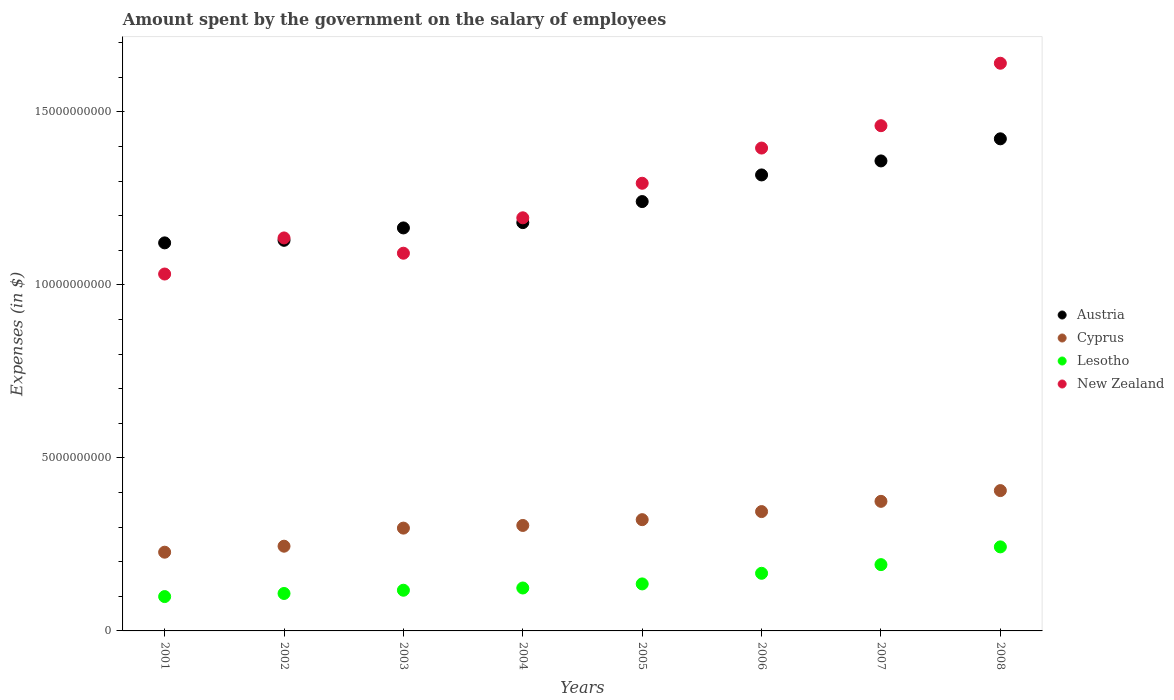How many different coloured dotlines are there?
Provide a short and direct response. 4. What is the amount spent on the salary of employees by the government in Lesotho in 2003?
Ensure brevity in your answer.  1.18e+09. Across all years, what is the maximum amount spent on the salary of employees by the government in Cyprus?
Offer a terse response. 4.06e+09. Across all years, what is the minimum amount spent on the salary of employees by the government in New Zealand?
Offer a terse response. 1.03e+1. In which year was the amount spent on the salary of employees by the government in Lesotho maximum?
Keep it short and to the point. 2008. In which year was the amount spent on the salary of employees by the government in Cyprus minimum?
Ensure brevity in your answer.  2001. What is the total amount spent on the salary of employees by the government in Lesotho in the graph?
Keep it short and to the point. 1.19e+1. What is the difference between the amount spent on the salary of employees by the government in New Zealand in 2002 and that in 2008?
Ensure brevity in your answer.  -5.05e+09. What is the difference between the amount spent on the salary of employees by the government in Lesotho in 2001 and the amount spent on the salary of employees by the government in New Zealand in 2005?
Your answer should be compact. -1.19e+1. What is the average amount spent on the salary of employees by the government in Austria per year?
Provide a short and direct response. 1.24e+1. In the year 2006, what is the difference between the amount spent on the salary of employees by the government in New Zealand and amount spent on the salary of employees by the government in Cyprus?
Your response must be concise. 1.05e+1. In how many years, is the amount spent on the salary of employees by the government in New Zealand greater than 12000000000 $?
Your answer should be very brief. 4. What is the ratio of the amount spent on the salary of employees by the government in Cyprus in 2003 to that in 2007?
Give a very brief answer. 0.79. Is the amount spent on the salary of employees by the government in Cyprus in 2002 less than that in 2003?
Keep it short and to the point. Yes. Is the difference between the amount spent on the salary of employees by the government in New Zealand in 2005 and 2008 greater than the difference between the amount spent on the salary of employees by the government in Cyprus in 2005 and 2008?
Your answer should be compact. No. What is the difference between the highest and the second highest amount spent on the salary of employees by the government in Austria?
Offer a very short reply. 6.39e+08. What is the difference between the highest and the lowest amount spent on the salary of employees by the government in Austria?
Ensure brevity in your answer.  3.01e+09. Is the sum of the amount spent on the salary of employees by the government in Lesotho in 2002 and 2005 greater than the maximum amount spent on the salary of employees by the government in Austria across all years?
Make the answer very short. No. Is the amount spent on the salary of employees by the government in Cyprus strictly less than the amount spent on the salary of employees by the government in Austria over the years?
Your response must be concise. Yes. How many dotlines are there?
Provide a short and direct response. 4. How many years are there in the graph?
Ensure brevity in your answer.  8. Are the values on the major ticks of Y-axis written in scientific E-notation?
Your answer should be compact. No. Does the graph contain grids?
Offer a very short reply. No. How many legend labels are there?
Your response must be concise. 4. What is the title of the graph?
Give a very brief answer. Amount spent by the government on the salary of employees. Does "St. Vincent and the Grenadines" appear as one of the legend labels in the graph?
Your answer should be very brief. No. What is the label or title of the Y-axis?
Provide a succinct answer. Expenses (in $). What is the Expenses (in $) of Austria in 2001?
Give a very brief answer. 1.12e+1. What is the Expenses (in $) in Cyprus in 2001?
Give a very brief answer. 2.28e+09. What is the Expenses (in $) of Lesotho in 2001?
Offer a terse response. 9.92e+08. What is the Expenses (in $) in New Zealand in 2001?
Give a very brief answer. 1.03e+1. What is the Expenses (in $) of Austria in 2002?
Your answer should be compact. 1.13e+1. What is the Expenses (in $) in Cyprus in 2002?
Your answer should be compact. 2.45e+09. What is the Expenses (in $) in Lesotho in 2002?
Your response must be concise. 1.08e+09. What is the Expenses (in $) in New Zealand in 2002?
Offer a very short reply. 1.14e+1. What is the Expenses (in $) in Austria in 2003?
Your answer should be very brief. 1.16e+1. What is the Expenses (in $) of Cyprus in 2003?
Provide a short and direct response. 2.97e+09. What is the Expenses (in $) in Lesotho in 2003?
Give a very brief answer. 1.18e+09. What is the Expenses (in $) of New Zealand in 2003?
Ensure brevity in your answer.  1.09e+1. What is the Expenses (in $) of Austria in 2004?
Your answer should be very brief. 1.18e+1. What is the Expenses (in $) in Cyprus in 2004?
Provide a short and direct response. 3.05e+09. What is the Expenses (in $) in Lesotho in 2004?
Your answer should be very brief. 1.24e+09. What is the Expenses (in $) of New Zealand in 2004?
Keep it short and to the point. 1.19e+1. What is the Expenses (in $) of Austria in 2005?
Keep it short and to the point. 1.24e+1. What is the Expenses (in $) of Cyprus in 2005?
Offer a very short reply. 3.22e+09. What is the Expenses (in $) in Lesotho in 2005?
Give a very brief answer. 1.36e+09. What is the Expenses (in $) of New Zealand in 2005?
Offer a very short reply. 1.29e+1. What is the Expenses (in $) in Austria in 2006?
Provide a short and direct response. 1.32e+1. What is the Expenses (in $) of Cyprus in 2006?
Keep it short and to the point. 3.45e+09. What is the Expenses (in $) in Lesotho in 2006?
Your answer should be compact. 1.67e+09. What is the Expenses (in $) in New Zealand in 2006?
Your response must be concise. 1.40e+1. What is the Expenses (in $) of Austria in 2007?
Give a very brief answer. 1.36e+1. What is the Expenses (in $) in Cyprus in 2007?
Keep it short and to the point. 3.74e+09. What is the Expenses (in $) of Lesotho in 2007?
Keep it short and to the point. 1.92e+09. What is the Expenses (in $) of New Zealand in 2007?
Your response must be concise. 1.46e+1. What is the Expenses (in $) in Austria in 2008?
Your answer should be very brief. 1.42e+1. What is the Expenses (in $) of Cyprus in 2008?
Offer a terse response. 4.06e+09. What is the Expenses (in $) in Lesotho in 2008?
Provide a short and direct response. 2.43e+09. What is the Expenses (in $) of New Zealand in 2008?
Ensure brevity in your answer.  1.64e+1. Across all years, what is the maximum Expenses (in $) in Austria?
Offer a very short reply. 1.42e+1. Across all years, what is the maximum Expenses (in $) in Cyprus?
Make the answer very short. 4.06e+09. Across all years, what is the maximum Expenses (in $) in Lesotho?
Your answer should be very brief. 2.43e+09. Across all years, what is the maximum Expenses (in $) of New Zealand?
Keep it short and to the point. 1.64e+1. Across all years, what is the minimum Expenses (in $) in Austria?
Ensure brevity in your answer.  1.12e+1. Across all years, what is the minimum Expenses (in $) in Cyprus?
Give a very brief answer. 2.28e+09. Across all years, what is the minimum Expenses (in $) in Lesotho?
Make the answer very short. 9.92e+08. Across all years, what is the minimum Expenses (in $) of New Zealand?
Give a very brief answer. 1.03e+1. What is the total Expenses (in $) of Austria in the graph?
Give a very brief answer. 9.93e+1. What is the total Expenses (in $) of Cyprus in the graph?
Keep it short and to the point. 2.52e+1. What is the total Expenses (in $) of Lesotho in the graph?
Offer a terse response. 1.19e+1. What is the total Expenses (in $) in New Zealand in the graph?
Ensure brevity in your answer.  1.02e+11. What is the difference between the Expenses (in $) in Austria in 2001 and that in 2002?
Ensure brevity in your answer.  -7.44e+07. What is the difference between the Expenses (in $) in Cyprus in 2001 and that in 2002?
Your answer should be very brief. -1.73e+08. What is the difference between the Expenses (in $) in Lesotho in 2001 and that in 2002?
Provide a succinct answer. -8.97e+07. What is the difference between the Expenses (in $) in New Zealand in 2001 and that in 2002?
Ensure brevity in your answer.  -1.04e+09. What is the difference between the Expenses (in $) in Austria in 2001 and that in 2003?
Your response must be concise. -4.32e+08. What is the difference between the Expenses (in $) of Cyprus in 2001 and that in 2003?
Make the answer very short. -6.96e+08. What is the difference between the Expenses (in $) in Lesotho in 2001 and that in 2003?
Make the answer very short. -1.83e+08. What is the difference between the Expenses (in $) of New Zealand in 2001 and that in 2003?
Provide a short and direct response. -6.01e+08. What is the difference between the Expenses (in $) of Austria in 2001 and that in 2004?
Provide a succinct answer. -5.86e+08. What is the difference between the Expenses (in $) in Cyprus in 2001 and that in 2004?
Your response must be concise. -7.73e+08. What is the difference between the Expenses (in $) of Lesotho in 2001 and that in 2004?
Your answer should be compact. -2.48e+08. What is the difference between the Expenses (in $) in New Zealand in 2001 and that in 2004?
Provide a short and direct response. -1.62e+09. What is the difference between the Expenses (in $) of Austria in 2001 and that in 2005?
Keep it short and to the point. -1.19e+09. What is the difference between the Expenses (in $) in Cyprus in 2001 and that in 2005?
Ensure brevity in your answer.  -9.40e+08. What is the difference between the Expenses (in $) of Lesotho in 2001 and that in 2005?
Offer a terse response. -3.66e+08. What is the difference between the Expenses (in $) in New Zealand in 2001 and that in 2005?
Offer a terse response. -2.62e+09. What is the difference between the Expenses (in $) of Austria in 2001 and that in 2006?
Your response must be concise. -1.96e+09. What is the difference between the Expenses (in $) of Cyprus in 2001 and that in 2006?
Provide a short and direct response. -1.17e+09. What is the difference between the Expenses (in $) of Lesotho in 2001 and that in 2006?
Your response must be concise. -6.73e+08. What is the difference between the Expenses (in $) of New Zealand in 2001 and that in 2006?
Your answer should be very brief. -3.64e+09. What is the difference between the Expenses (in $) of Austria in 2001 and that in 2007?
Provide a succinct answer. -2.37e+09. What is the difference between the Expenses (in $) in Cyprus in 2001 and that in 2007?
Make the answer very short. -1.47e+09. What is the difference between the Expenses (in $) of Lesotho in 2001 and that in 2007?
Provide a short and direct response. -9.23e+08. What is the difference between the Expenses (in $) of New Zealand in 2001 and that in 2007?
Your answer should be compact. -4.29e+09. What is the difference between the Expenses (in $) in Austria in 2001 and that in 2008?
Keep it short and to the point. -3.01e+09. What is the difference between the Expenses (in $) of Cyprus in 2001 and that in 2008?
Your response must be concise. -1.78e+09. What is the difference between the Expenses (in $) in Lesotho in 2001 and that in 2008?
Provide a short and direct response. -1.44e+09. What is the difference between the Expenses (in $) in New Zealand in 2001 and that in 2008?
Offer a very short reply. -6.09e+09. What is the difference between the Expenses (in $) of Austria in 2002 and that in 2003?
Ensure brevity in your answer.  -3.58e+08. What is the difference between the Expenses (in $) in Cyprus in 2002 and that in 2003?
Give a very brief answer. -5.22e+08. What is the difference between the Expenses (in $) of Lesotho in 2002 and that in 2003?
Provide a succinct answer. -9.38e+07. What is the difference between the Expenses (in $) of New Zealand in 2002 and that in 2003?
Your answer should be very brief. 4.41e+08. What is the difference between the Expenses (in $) of Austria in 2002 and that in 2004?
Ensure brevity in your answer.  -5.11e+08. What is the difference between the Expenses (in $) in Cyprus in 2002 and that in 2004?
Your answer should be compact. -5.99e+08. What is the difference between the Expenses (in $) of Lesotho in 2002 and that in 2004?
Provide a succinct answer. -1.58e+08. What is the difference between the Expenses (in $) of New Zealand in 2002 and that in 2004?
Provide a short and direct response. -5.82e+08. What is the difference between the Expenses (in $) of Austria in 2002 and that in 2005?
Offer a terse response. -1.12e+09. What is the difference between the Expenses (in $) in Cyprus in 2002 and that in 2005?
Your response must be concise. -7.67e+08. What is the difference between the Expenses (in $) of Lesotho in 2002 and that in 2005?
Your answer should be very brief. -2.76e+08. What is the difference between the Expenses (in $) of New Zealand in 2002 and that in 2005?
Your answer should be compact. -1.58e+09. What is the difference between the Expenses (in $) in Austria in 2002 and that in 2006?
Your answer should be very brief. -1.89e+09. What is the difference between the Expenses (in $) of Cyprus in 2002 and that in 2006?
Your answer should be very brief. -1.00e+09. What is the difference between the Expenses (in $) of Lesotho in 2002 and that in 2006?
Make the answer very short. -5.83e+08. What is the difference between the Expenses (in $) in New Zealand in 2002 and that in 2006?
Your response must be concise. -2.60e+09. What is the difference between the Expenses (in $) in Austria in 2002 and that in 2007?
Give a very brief answer. -2.29e+09. What is the difference between the Expenses (in $) in Cyprus in 2002 and that in 2007?
Keep it short and to the point. -1.30e+09. What is the difference between the Expenses (in $) of Lesotho in 2002 and that in 2007?
Ensure brevity in your answer.  -8.34e+08. What is the difference between the Expenses (in $) in New Zealand in 2002 and that in 2007?
Ensure brevity in your answer.  -3.24e+09. What is the difference between the Expenses (in $) of Austria in 2002 and that in 2008?
Your answer should be very brief. -2.93e+09. What is the difference between the Expenses (in $) in Cyprus in 2002 and that in 2008?
Ensure brevity in your answer.  -1.61e+09. What is the difference between the Expenses (in $) in Lesotho in 2002 and that in 2008?
Your answer should be very brief. -1.35e+09. What is the difference between the Expenses (in $) in New Zealand in 2002 and that in 2008?
Offer a very short reply. -5.05e+09. What is the difference between the Expenses (in $) of Austria in 2003 and that in 2004?
Your answer should be very brief. -1.53e+08. What is the difference between the Expenses (in $) of Cyprus in 2003 and that in 2004?
Give a very brief answer. -7.69e+07. What is the difference between the Expenses (in $) of Lesotho in 2003 and that in 2004?
Provide a short and direct response. -6.46e+07. What is the difference between the Expenses (in $) in New Zealand in 2003 and that in 2004?
Give a very brief answer. -1.02e+09. What is the difference between the Expenses (in $) of Austria in 2003 and that in 2005?
Make the answer very short. -7.62e+08. What is the difference between the Expenses (in $) of Cyprus in 2003 and that in 2005?
Keep it short and to the point. -2.44e+08. What is the difference between the Expenses (in $) of Lesotho in 2003 and that in 2005?
Your response must be concise. -1.82e+08. What is the difference between the Expenses (in $) in New Zealand in 2003 and that in 2005?
Provide a succinct answer. -2.02e+09. What is the difference between the Expenses (in $) in Austria in 2003 and that in 2006?
Your answer should be compact. -1.53e+09. What is the difference between the Expenses (in $) in Cyprus in 2003 and that in 2006?
Offer a very short reply. -4.78e+08. What is the difference between the Expenses (in $) of Lesotho in 2003 and that in 2006?
Your answer should be compact. -4.90e+08. What is the difference between the Expenses (in $) in New Zealand in 2003 and that in 2006?
Your response must be concise. -3.04e+09. What is the difference between the Expenses (in $) of Austria in 2003 and that in 2007?
Ensure brevity in your answer.  -1.94e+09. What is the difference between the Expenses (in $) in Cyprus in 2003 and that in 2007?
Make the answer very short. -7.74e+08. What is the difference between the Expenses (in $) in Lesotho in 2003 and that in 2007?
Your answer should be compact. -7.40e+08. What is the difference between the Expenses (in $) in New Zealand in 2003 and that in 2007?
Your answer should be compact. -3.68e+09. What is the difference between the Expenses (in $) of Austria in 2003 and that in 2008?
Offer a terse response. -2.57e+09. What is the difference between the Expenses (in $) of Cyprus in 2003 and that in 2008?
Offer a terse response. -1.08e+09. What is the difference between the Expenses (in $) in Lesotho in 2003 and that in 2008?
Keep it short and to the point. -1.25e+09. What is the difference between the Expenses (in $) in New Zealand in 2003 and that in 2008?
Keep it short and to the point. -5.49e+09. What is the difference between the Expenses (in $) of Austria in 2004 and that in 2005?
Your answer should be very brief. -6.08e+08. What is the difference between the Expenses (in $) in Cyprus in 2004 and that in 2005?
Give a very brief answer. -1.67e+08. What is the difference between the Expenses (in $) in Lesotho in 2004 and that in 2005?
Provide a succinct answer. -1.18e+08. What is the difference between the Expenses (in $) in New Zealand in 2004 and that in 2005?
Ensure brevity in your answer.  -9.98e+08. What is the difference between the Expenses (in $) in Austria in 2004 and that in 2006?
Provide a short and direct response. -1.38e+09. What is the difference between the Expenses (in $) in Cyprus in 2004 and that in 2006?
Give a very brief answer. -4.01e+08. What is the difference between the Expenses (in $) in Lesotho in 2004 and that in 2006?
Offer a terse response. -4.25e+08. What is the difference between the Expenses (in $) of New Zealand in 2004 and that in 2006?
Offer a very short reply. -2.02e+09. What is the difference between the Expenses (in $) of Austria in 2004 and that in 2007?
Provide a succinct answer. -1.78e+09. What is the difference between the Expenses (in $) in Cyprus in 2004 and that in 2007?
Provide a short and direct response. -6.97e+08. What is the difference between the Expenses (in $) in Lesotho in 2004 and that in 2007?
Keep it short and to the point. -6.75e+08. What is the difference between the Expenses (in $) of New Zealand in 2004 and that in 2007?
Provide a short and direct response. -2.66e+09. What is the difference between the Expenses (in $) of Austria in 2004 and that in 2008?
Offer a very short reply. -2.42e+09. What is the difference between the Expenses (in $) in Cyprus in 2004 and that in 2008?
Provide a short and direct response. -1.01e+09. What is the difference between the Expenses (in $) of Lesotho in 2004 and that in 2008?
Your answer should be compact. -1.19e+09. What is the difference between the Expenses (in $) in New Zealand in 2004 and that in 2008?
Make the answer very short. -4.47e+09. What is the difference between the Expenses (in $) in Austria in 2005 and that in 2006?
Ensure brevity in your answer.  -7.70e+08. What is the difference between the Expenses (in $) in Cyprus in 2005 and that in 2006?
Offer a terse response. -2.33e+08. What is the difference between the Expenses (in $) of Lesotho in 2005 and that in 2006?
Provide a short and direct response. -3.07e+08. What is the difference between the Expenses (in $) in New Zealand in 2005 and that in 2006?
Provide a succinct answer. -1.02e+09. What is the difference between the Expenses (in $) of Austria in 2005 and that in 2007?
Your answer should be compact. -1.17e+09. What is the difference between the Expenses (in $) in Cyprus in 2005 and that in 2007?
Provide a short and direct response. -5.29e+08. What is the difference between the Expenses (in $) of Lesotho in 2005 and that in 2007?
Make the answer very short. -5.57e+08. What is the difference between the Expenses (in $) in New Zealand in 2005 and that in 2007?
Your answer should be compact. -1.66e+09. What is the difference between the Expenses (in $) of Austria in 2005 and that in 2008?
Your answer should be compact. -1.81e+09. What is the difference between the Expenses (in $) in Cyprus in 2005 and that in 2008?
Make the answer very short. -8.40e+08. What is the difference between the Expenses (in $) of Lesotho in 2005 and that in 2008?
Offer a terse response. -1.07e+09. What is the difference between the Expenses (in $) in New Zealand in 2005 and that in 2008?
Your answer should be very brief. -3.47e+09. What is the difference between the Expenses (in $) of Austria in 2006 and that in 2007?
Make the answer very short. -4.05e+08. What is the difference between the Expenses (in $) of Cyprus in 2006 and that in 2007?
Give a very brief answer. -2.96e+08. What is the difference between the Expenses (in $) in Lesotho in 2006 and that in 2007?
Offer a terse response. -2.50e+08. What is the difference between the Expenses (in $) of New Zealand in 2006 and that in 2007?
Keep it short and to the point. -6.46e+08. What is the difference between the Expenses (in $) in Austria in 2006 and that in 2008?
Your answer should be compact. -1.04e+09. What is the difference between the Expenses (in $) of Cyprus in 2006 and that in 2008?
Offer a terse response. -6.06e+08. What is the difference between the Expenses (in $) of Lesotho in 2006 and that in 2008?
Ensure brevity in your answer.  -7.63e+08. What is the difference between the Expenses (in $) of New Zealand in 2006 and that in 2008?
Keep it short and to the point. -2.45e+09. What is the difference between the Expenses (in $) of Austria in 2007 and that in 2008?
Your answer should be very brief. -6.39e+08. What is the difference between the Expenses (in $) in Cyprus in 2007 and that in 2008?
Provide a succinct answer. -3.10e+08. What is the difference between the Expenses (in $) in Lesotho in 2007 and that in 2008?
Provide a succinct answer. -5.13e+08. What is the difference between the Expenses (in $) of New Zealand in 2007 and that in 2008?
Provide a short and direct response. -1.80e+09. What is the difference between the Expenses (in $) in Austria in 2001 and the Expenses (in $) in Cyprus in 2002?
Your response must be concise. 8.77e+09. What is the difference between the Expenses (in $) in Austria in 2001 and the Expenses (in $) in Lesotho in 2002?
Make the answer very short. 1.01e+1. What is the difference between the Expenses (in $) of Austria in 2001 and the Expenses (in $) of New Zealand in 2002?
Your answer should be very brief. -1.42e+08. What is the difference between the Expenses (in $) in Cyprus in 2001 and the Expenses (in $) in Lesotho in 2002?
Make the answer very short. 1.19e+09. What is the difference between the Expenses (in $) in Cyprus in 2001 and the Expenses (in $) in New Zealand in 2002?
Your response must be concise. -9.08e+09. What is the difference between the Expenses (in $) of Lesotho in 2001 and the Expenses (in $) of New Zealand in 2002?
Offer a very short reply. -1.04e+1. What is the difference between the Expenses (in $) of Austria in 2001 and the Expenses (in $) of Cyprus in 2003?
Make the answer very short. 8.24e+09. What is the difference between the Expenses (in $) in Austria in 2001 and the Expenses (in $) in Lesotho in 2003?
Make the answer very short. 1.00e+1. What is the difference between the Expenses (in $) of Austria in 2001 and the Expenses (in $) of New Zealand in 2003?
Your answer should be very brief. 2.99e+08. What is the difference between the Expenses (in $) of Cyprus in 2001 and the Expenses (in $) of Lesotho in 2003?
Your response must be concise. 1.10e+09. What is the difference between the Expenses (in $) in Cyprus in 2001 and the Expenses (in $) in New Zealand in 2003?
Offer a very short reply. -8.64e+09. What is the difference between the Expenses (in $) of Lesotho in 2001 and the Expenses (in $) of New Zealand in 2003?
Your answer should be very brief. -9.92e+09. What is the difference between the Expenses (in $) in Austria in 2001 and the Expenses (in $) in Cyprus in 2004?
Provide a succinct answer. 8.17e+09. What is the difference between the Expenses (in $) of Austria in 2001 and the Expenses (in $) of Lesotho in 2004?
Keep it short and to the point. 9.97e+09. What is the difference between the Expenses (in $) of Austria in 2001 and the Expenses (in $) of New Zealand in 2004?
Your response must be concise. -7.25e+08. What is the difference between the Expenses (in $) of Cyprus in 2001 and the Expenses (in $) of Lesotho in 2004?
Your response must be concise. 1.03e+09. What is the difference between the Expenses (in $) of Cyprus in 2001 and the Expenses (in $) of New Zealand in 2004?
Offer a terse response. -9.66e+09. What is the difference between the Expenses (in $) in Lesotho in 2001 and the Expenses (in $) in New Zealand in 2004?
Make the answer very short. -1.09e+1. What is the difference between the Expenses (in $) of Austria in 2001 and the Expenses (in $) of Cyprus in 2005?
Provide a short and direct response. 8.00e+09. What is the difference between the Expenses (in $) in Austria in 2001 and the Expenses (in $) in Lesotho in 2005?
Your response must be concise. 9.86e+09. What is the difference between the Expenses (in $) in Austria in 2001 and the Expenses (in $) in New Zealand in 2005?
Offer a very short reply. -1.72e+09. What is the difference between the Expenses (in $) in Cyprus in 2001 and the Expenses (in $) in Lesotho in 2005?
Give a very brief answer. 9.17e+08. What is the difference between the Expenses (in $) in Cyprus in 2001 and the Expenses (in $) in New Zealand in 2005?
Give a very brief answer. -1.07e+1. What is the difference between the Expenses (in $) of Lesotho in 2001 and the Expenses (in $) of New Zealand in 2005?
Make the answer very short. -1.19e+1. What is the difference between the Expenses (in $) of Austria in 2001 and the Expenses (in $) of Cyprus in 2006?
Ensure brevity in your answer.  7.77e+09. What is the difference between the Expenses (in $) in Austria in 2001 and the Expenses (in $) in Lesotho in 2006?
Offer a very short reply. 9.55e+09. What is the difference between the Expenses (in $) in Austria in 2001 and the Expenses (in $) in New Zealand in 2006?
Provide a short and direct response. -2.74e+09. What is the difference between the Expenses (in $) of Cyprus in 2001 and the Expenses (in $) of Lesotho in 2006?
Your response must be concise. 6.10e+08. What is the difference between the Expenses (in $) in Cyprus in 2001 and the Expenses (in $) in New Zealand in 2006?
Make the answer very short. -1.17e+1. What is the difference between the Expenses (in $) of Lesotho in 2001 and the Expenses (in $) of New Zealand in 2006?
Your response must be concise. -1.30e+1. What is the difference between the Expenses (in $) of Austria in 2001 and the Expenses (in $) of Cyprus in 2007?
Your response must be concise. 7.47e+09. What is the difference between the Expenses (in $) of Austria in 2001 and the Expenses (in $) of Lesotho in 2007?
Ensure brevity in your answer.  9.30e+09. What is the difference between the Expenses (in $) of Austria in 2001 and the Expenses (in $) of New Zealand in 2007?
Provide a short and direct response. -3.39e+09. What is the difference between the Expenses (in $) of Cyprus in 2001 and the Expenses (in $) of Lesotho in 2007?
Your response must be concise. 3.60e+08. What is the difference between the Expenses (in $) in Cyprus in 2001 and the Expenses (in $) in New Zealand in 2007?
Provide a short and direct response. -1.23e+1. What is the difference between the Expenses (in $) of Lesotho in 2001 and the Expenses (in $) of New Zealand in 2007?
Ensure brevity in your answer.  -1.36e+1. What is the difference between the Expenses (in $) in Austria in 2001 and the Expenses (in $) in Cyprus in 2008?
Your response must be concise. 7.16e+09. What is the difference between the Expenses (in $) in Austria in 2001 and the Expenses (in $) in Lesotho in 2008?
Offer a very short reply. 8.79e+09. What is the difference between the Expenses (in $) of Austria in 2001 and the Expenses (in $) of New Zealand in 2008?
Provide a short and direct response. -5.19e+09. What is the difference between the Expenses (in $) of Cyprus in 2001 and the Expenses (in $) of Lesotho in 2008?
Offer a very short reply. -1.53e+08. What is the difference between the Expenses (in $) of Cyprus in 2001 and the Expenses (in $) of New Zealand in 2008?
Your answer should be compact. -1.41e+1. What is the difference between the Expenses (in $) in Lesotho in 2001 and the Expenses (in $) in New Zealand in 2008?
Provide a succinct answer. -1.54e+1. What is the difference between the Expenses (in $) of Austria in 2002 and the Expenses (in $) of Cyprus in 2003?
Make the answer very short. 8.32e+09. What is the difference between the Expenses (in $) of Austria in 2002 and the Expenses (in $) of Lesotho in 2003?
Offer a very short reply. 1.01e+1. What is the difference between the Expenses (in $) in Austria in 2002 and the Expenses (in $) in New Zealand in 2003?
Your answer should be compact. 3.73e+08. What is the difference between the Expenses (in $) of Cyprus in 2002 and the Expenses (in $) of Lesotho in 2003?
Provide a succinct answer. 1.27e+09. What is the difference between the Expenses (in $) in Cyprus in 2002 and the Expenses (in $) in New Zealand in 2003?
Offer a very short reply. -8.47e+09. What is the difference between the Expenses (in $) in Lesotho in 2002 and the Expenses (in $) in New Zealand in 2003?
Your answer should be very brief. -9.83e+09. What is the difference between the Expenses (in $) in Austria in 2002 and the Expenses (in $) in Cyprus in 2004?
Make the answer very short. 8.24e+09. What is the difference between the Expenses (in $) in Austria in 2002 and the Expenses (in $) in Lesotho in 2004?
Your answer should be compact. 1.00e+1. What is the difference between the Expenses (in $) in Austria in 2002 and the Expenses (in $) in New Zealand in 2004?
Provide a short and direct response. -6.50e+08. What is the difference between the Expenses (in $) of Cyprus in 2002 and the Expenses (in $) of Lesotho in 2004?
Provide a short and direct response. 1.21e+09. What is the difference between the Expenses (in $) in Cyprus in 2002 and the Expenses (in $) in New Zealand in 2004?
Your response must be concise. -9.49e+09. What is the difference between the Expenses (in $) in Lesotho in 2002 and the Expenses (in $) in New Zealand in 2004?
Your answer should be compact. -1.09e+1. What is the difference between the Expenses (in $) in Austria in 2002 and the Expenses (in $) in Cyprus in 2005?
Make the answer very short. 8.07e+09. What is the difference between the Expenses (in $) in Austria in 2002 and the Expenses (in $) in Lesotho in 2005?
Your answer should be very brief. 9.93e+09. What is the difference between the Expenses (in $) of Austria in 2002 and the Expenses (in $) of New Zealand in 2005?
Your response must be concise. -1.65e+09. What is the difference between the Expenses (in $) of Cyprus in 2002 and the Expenses (in $) of Lesotho in 2005?
Your answer should be compact. 1.09e+09. What is the difference between the Expenses (in $) in Cyprus in 2002 and the Expenses (in $) in New Zealand in 2005?
Keep it short and to the point. -1.05e+1. What is the difference between the Expenses (in $) of Lesotho in 2002 and the Expenses (in $) of New Zealand in 2005?
Ensure brevity in your answer.  -1.19e+1. What is the difference between the Expenses (in $) of Austria in 2002 and the Expenses (in $) of Cyprus in 2006?
Your response must be concise. 7.84e+09. What is the difference between the Expenses (in $) of Austria in 2002 and the Expenses (in $) of Lesotho in 2006?
Ensure brevity in your answer.  9.62e+09. What is the difference between the Expenses (in $) in Austria in 2002 and the Expenses (in $) in New Zealand in 2006?
Give a very brief answer. -2.67e+09. What is the difference between the Expenses (in $) in Cyprus in 2002 and the Expenses (in $) in Lesotho in 2006?
Your answer should be compact. 7.83e+08. What is the difference between the Expenses (in $) of Cyprus in 2002 and the Expenses (in $) of New Zealand in 2006?
Ensure brevity in your answer.  -1.15e+1. What is the difference between the Expenses (in $) in Lesotho in 2002 and the Expenses (in $) in New Zealand in 2006?
Give a very brief answer. -1.29e+1. What is the difference between the Expenses (in $) in Austria in 2002 and the Expenses (in $) in Cyprus in 2007?
Keep it short and to the point. 7.54e+09. What is the difference between the Expenses (in $) of Austria in 2002 and the Expenses (in $) of Lesotho in 2007?
Ensure brevity in your answer.  9.37e+09. What is the difference between the Expenses (in $) of Austria in 2002 and the Expenses (in $) of New Zealand in 2007?
Ensure brevity in your answer.  -3.31e+09. What is the difference between the Expenses (in $) of Cyprus in 2002 and the Expenses (in $) of Lesotho in 2007?
Your answer should be very brief. 5.33e+08. What is the difference between the Expenses (in $) of Cyprus in 2002 and the Expenses (in $) of New Zealand in 2007?
Provide a succinct answer. -1.22e+1. What is the difference between the Expenses (in $) of Lesotho in 2002 and the Expenses (in $) of New Zealand in 2007?
Give a very brief answer. -1.35e+1. What is the difference between the Expenses (in $) in Austria in 2002 and the Expenses (in $) in Cyprus in 2008?
Offer a terse response. 7.23e+09. What is the difference between the Expenses (in $) in Austria in 2002 and the Expenses (in $) in Lesotho in 2008?
Your answer should be very brief. 8.86e+09. What is the difference between the Expenses (in $) of Austria in 2002 and the Expenses (in $) of New Zealand in 2008?
Your answer should be compact. -5.12e+09. What is the difference between the Expenses (in $) in Cyprus in 2002 and the Expenses (in $) in Lesotho in 2008?
Offer a very short reply. 1.99e+07. What is the difference between the Expenses (in $) in Cyprus in 2002 and the Expenses (in $) in New Zealand in 2008?
Your answer should be very brief. -1.40e+1. What is the difference between the Expenses (in $) in Lesotho in 2002 and the Expenses (in $) in New Zealand in 2008?
Keep it short and to the point. -1.53e+1. What is the difference between the Expenses (in $) in Austria in 2003 and the Expenses (in $) in Cyprus in 2004?
Your response must be concise. 8.60e+09. What is the difference between the Expenses (in $) in Austria in 2003 and the Expenses (in $) in Lesotho in 2004?
Provide a short and direct response. 1.04e+1. What is the difference between the Expenses (in $) in Austria in 2003 and the Expenses (in $) in New Zealand in 2004?
Offer a very short reply. -2.93e+08. What is the difference between the Expenses (in $) in Cyprus in 2003 and the Expenses (in $) in Lesotho in 2004?
Your answer should be very brief. 1.73e+09. What is the difference between the Expenses (in $) of Cyprus in 2003 and the Expenses (in $) of New Zealand in 2004?
Your answer should be very brief. -8.97e+09. What is the difference between the Expenses (in $) of Lesotho in 2003 and the Expenses (in $) of New Zealand in 2004?
Make the answer very short. -1.08e+1. What is the difference between the Expenses (in $) of Austria in 2003 and the Expenses (in $) of Cyprus in 2005?
Offer a terse response. 8.43e+09. What is the difference between the Expenses (in $) of Austria in 2003 and the Expenses (in $) of Lesotho in 2005?
Your response must be concise. 1.03e+1. What is the difference between the Expenses (in $) of Austria in 2003 and the Expenses (in $) of New Zealand in 2005?
Make the answer very short. -1.29e+09. What is the difference between the Expenses (in $) of Cyprus in 2003 and the Expenses (in $) of Lesotho in 2005?
Ensure brevity in your answer.  1.61e+09. What is the difference between the Expenses (in $) in Cyprus in 2003 and the Expenses (in $) in New Zealand in 2005?
Offer a terse response. -9.97e+09. What is the difference between the Expenses (in $) in Lesotho in 2003 and the Expenses (in $) in New Zealand in 2005?
Your answer should be very brief. -1.18e+1. What is the difference between the Expenses (in $) of Austria in 2003 and the Expenses (in $) of Cyprus in 2006?
Your answer should be compact. 8.20e+09. What is the difference between the Expenses (in $) of Austria in 2003 and the Expenses (in $) of Lesotho in 2006?
Offer a terse response. 9.98e+09. What is the difference between the Expenses (in $) in Austria in 2003 and the Expenses (in $) in New Zealand in 2006?
Your answer should be compact. -2.31e+09. What is the difference between the Expenses (in $) of Cyprus in 2003 and the Expenses (in $) of Lesotho in 2006?
Ensure brevity in your answer.  1.31e+09. What is the difference between the Expenses (in $) in Cyprus in 2003 and the Expenses (in $) in New Zealand in 2006?
Give a very brief answer. -1.10e+1. What is the difference between the Expenses (in $) of Lesotho in 2003 and the Expenses (in $) of New Zealand in 2006?
Your answer should be very brief. -1.28e+1. What is the difference between the Expenses (in $) in Austria in 2003 and the Expenses (in $) in Cyprus in 2007?
Give a very brief answer. 7.90e+09. What is the difference between the Expenses (in $) in Austria in 2003 and the Expenses (in $) in Lesotho in 2007?
Your response must be concise. 9.73e+09. What is the difference between the Expenses (in $) in Austria in 2003 and the Expenses (in $) in New Zealand in 2007?
Your answer should be very brief. -2.95e+09. What is the difference between the Expenses (in $) in Cyprus in 2003 and the Expenses (in $) in Lesotho in 2007?
Your answer should be compact. 1.06e+09. What is the difference between the Expenses (in $) of Cyprus in 2003 and the Expenses (in $) of New Zealand in 2007?
Offer a very short reply. -1.16e+1. What is the difference between the Expenses (in $) in Lesotho in 2003 and the Expenses (in $) in New Zealand in 2007?
Offer a very short reply. -1.34e+1. What is the difference between the Expenses (in $) in Austria in 2003 and the Expenses (in $) in Cyprus in 2008?
Keep it short and to the point. 7.59e+09. What is the difference between the Expenses (in $) of Austria in 2003 and the Expenses (in $) of Lesotho in 2008?
Offer a very short reply. 9.22e+09. What is the difference between the Expenses (in $) in Austria in 2003 and the Expenses (in $) in New Zealand in 2008?
Your response must be concise. -4.76e+09. What is the difference between the Expenses (in $) in Cyprus in 2003 and the Expenses (in $) in Lesotho in 2008?
Your answer should be compact. 5.42e+08. What is the difference between the Expenses (in $) of Cyprus in 2003 and the Expenses (in $) of New Zealand in 2008?
Your answer should be very brief. -1.34e+1. What is the difference between the Expenses (in $) in Lesotho in 2003 and the Expenses (in $) in New Zealand in 2008?
Keep it short and to the point. -1.52e+1. What is the difference between the Expenses (in $) in Austria in 2004 and the Expenses (in $) in Cyprus in 2005?
Your response must be concise. 8.58e+09. What is the difference between the Expenses (in $) of Austria in 2004 and the Expenses (in $) of Lesotho in 2005?
Make the answer very short. 1.04e+1. What is the difference between the Expenses (in $) of Austria in 2004 and the Expenses (in $) of New Zealand in 2005?
Your answer should be very brief. -1.14e+09. What is the difference between the Expenses (in $) of Cyprus in 2004 and the Expenses (in $) of Lesotho in 2005?
Provide a succinct answer. 1.69e+09. What is the difference between the Expenses (in $) of Cyprus in 2004 and the Expenses (in $) of New Zealand in 2005?
Your answer should be very brief. -9.89e+09. What is the difference between the Expenses (in $) in Lesotho in 2004 and the Expenses (in $) in New Zealand in 2005?
Offer a terse response. -1.17e+1. What is the difference between the Expenses (in $) of Austria in 2004 and the Expenses (in $) of Cyprus in 2006?
Offer a very short reply. 8.35e+09. What is the difference between the Expenses (in $) in Austria in 2004 and the Expenses (in $) in Lesotho in 2006?
Keep it short and to the point. 1.01e+1. What is the difference between the Expenses (in $) of Austria in 2004 and the Expenses (in $) of New Zealand in 2006?
Give a very brief answer. -2.15e+09. What is the difference between the Expenses (in $) in Cyprus in 2004 and the Expenses (in $) in Lesotho in 2006?
Your answer should be very brief. 1.38e+09. What is the difference between the Expenses (in $) in Cyprus in 2004 and the Expenses (in $) in New Zealand in 2006?
Keep it short and to the point. -1.09e+1. What is the difference between the Expenses (in $) in Lesotho in 2004 and the Expenses (in $) in New Zealand in 2006?
Your response must be concise. -1.27e+1. What is the difference between the Expenses (in $) in Austria in 2004 and the Expenses (in $) in Cyprus in 2007?
Your answer should be very brief. 8.05e+09. What is the difference between the Expenses (in $) of Austria in 2004 and the Expenses (in $) of Lesotho in 2007?
Provide a short and direct response. 9.88e+09. What is the difference between the Expenses (in $) in Austria in 2004 and the Expenses (in $) in New Zealand in 2007?
Your answer should be very brief. -2.80e+09. What is the difference between the Expenses (in $) of Cyprus in 2004 and the Expenses (in $) of Lesotho in 2007?
Provide a succinct answer. 1.13e+09. What is the difference between the Expenses (in $) in Cyprus in 2004 and the Expenses (in $) in New Zealand in 2007?
Offer a terse response. -1.16e+1. What is the difference between the Expenses (in $) of Lesotho in 2004 and the Expenses (in $) of New Zealand in 2007?
Provide a succinct answer. -1.34e+1. What is the difference between the Expenses (in $) in Austria in 2004 and the Expenses (in $) in Cyprus in 2008?
Offer a very short reply. 7.74e+09. What is the difference between the Expenses (in $) in Austria in 2004 and the Expenses (in $) in Lesotho in 2008?
Your answer should be compact. 9.37e+09. What is the difference between the Expenses (in $) in Austria in 2004 and the Expenses (in $) in New Zealand in 2008?
Make the answer very short. -4.61e+09. What is the difference between the Expenses (in $) of Cyprus in 2004 and the Expenses (in $) of Lesotho in 2008?
Offer a terse response. 6.19e+08. What is the difference between the Expenses (in $) of Cyprus in 2004 and the Expenses (in $) of New Zealand in 2008?
Your response must be concise. -1.34e+1. What is the difference between the Expenses (in $) in Lesotho in 2004 and the Expenses (in $) in New Zealand in 2008?
Your answer should be compact. -1.52e+1. What is the difference between the Expenses (in $) of Austria in 2005 and the Expenses (in $) of Cyprus in 2006?
Provide a succinct answer. 8.96e+09. What is the difference between the Expenses (in $) of Austria in 2005 and the Expenses (in $) of Lesotho in 2006?
Make the answer very short. 1.07e+1. What is the difference between the Expenses (in $) in Austria in 2005 and the Expenses (in $) in New Zealand in 2006?
Offer a very short reply. -1.55e+09. What is the difference between the Expenses (in $) in Cyprus in 2005 and the Expenses (in $) in Lesotho in 2006?
Give a very brief answer. 1.55e+09. What is the difference between the Expenses (in $) in Cyprus in 2005 and the Expenses (in $) in New Zealand in 2006?
Keep it short and to the point. -1.07e+1. What is the difference between the Expenses (in $) of Lesotho in 2005 and the Expenses (in $) of New Zealand in 2006?
Your response must be concise. -1.26e+1. What is the difference between the Expenses (in $) in Austria in 2005 and the Expenses (in $) in Cyprus in 2007?
Keep it short and to the point. 8.66e+09. What is the difference between the Expenses (in $) of Austria in 2005 and the Expenses (in $) of Lesotho in 2007?
Offer a very short reply. 1.05e+1. What is the difference between the Expenses (in $) of Austria in 2005 and the Expenses (in $) of New Zealand in 2007?
Provide a succinct answer. -2.19e+09. What is the difference between the Expenses (in $) of Cyprus in 2005 and the Expenses (in $) of Lesotho in 2007?
Your answer should be very brief. 1.30e+09. What is the difference between the Expenses (in $) in Cyprus in 2005 and the Expenses (in $) in New Zealand in 2007?
Give a very brief answer. -1.14e+1. What is the difference between the Expenses (in $) in Lesotho in 2005 and the Expenses (in $) in New Zealand in 2007?
Provide a succinct answer. -1.32e+1. What is the difference between the Expenses (in $) in Austria in 2005 and the Expenses (in $) in Cyprus in 2008?
Provide a succinct answer. 8.35e+09. What is the difference between the Expenses (in $) in Austria in 2005 and the Expenses (in $) in Lesotho in 2008?
Provide a succinct answer. 9.98e+09. What is the difference between the Expenses (in $) of Austria in 2005 and the Expenses (in $) of New Zealand in 2008?
Your answer should be very brief. -4.00e+09. What is the difference between the Expenses (in $) of Cyprus in 2005 and the Expenses (in $) of Lesotho in 2008?
Offer a very short reply. 7.87e+08. What is the difference between the Expenses (in $) of Cyprus in 2005 and the Expenses (in $) of New Zealand in 2008?
Your answer should be very brief. -1.32e+1. What is the difference between the Expenses (in $) of Lesotho in 2005 and the Expenses (in $) of New Zealand in 2008?
Offer a very short reply. -1.50e+1. What is the difference between the Expenses (in $) in Austria in 2006 and the Expenses (in $) in Cyprus in 2007?
Your answer should be compact. 9.43e+09. What is the difference between the Expenses (in $) in Austria in 2006 and the Expenses (in $) in Lesotho in 2007?
Make the answer very short. 1.13e+1. What is the difference between the Expenses (in $) of Austria in 2006 and the Expenses (in $) of New Zealand in 2007?
Provide a short and direct response. -1.42e+09. What is the difference between the Expenses (in $) in Cyprus in 2006 and the Expenses (in $) in Lesotho in 2007?
Your answer should be compact. 1.53e+09. What is the difference between the Expenses (in $) of Cyprus in 2006 and the Expenses (in $) of New Zealand in 2007?
Keep it short and to the point. -1.12e+1. What is the difference between the Expenses (in $) of Lesotho in 2006 and the Expenses (in $) of New Zealand in 2007?
Provide a succinct answer. -1.29e+1. What is the difference between the Expenses (in $) in Austria in 2006 and the Expenses (in $) in Cyprus in 2008?
Make the answer very short. 9.12e+09. What is the difference between the Expenses (in $) of Austria in 2006 and the Expenses (in $) of Lesotho in 2008?
Your answer should be very brief. 1.07e+1. What is the difference between the Expenses (in $) of Austria in 2006 and the Expenses (in $) of New Zealand in 2008?
Make the answer very short. -3.23e+09. What is the difference between the Expenses (in $) in Cyprus in 2006 and the Expenses (in $) in Lesotho in 2008?
Offer a very short reply. 1.02e+09. What is the difference between the Expenses (in $) in Cyprus in 2006 and the Expenses (in $) in New Zealand in 2008?
Give a very brief answer. -1.30e+1. What is the difference between the Expenses (in $) of Lesotho in 2006 and the Expenses (in $) of New Zealand in 2008?
Offer a terse response. -1.47e+1. What is the difference between the Expenses (in $) of Austria in 2007 and the Expenses (in $) of Cyprus in 2008?
Offer a very short reply. 9.53e+09. What is the difference between the Expenses (in $) in Austria in 2007 and the Expenses (in $) in Lesotho in 2008?
Your answer should be compact. 1.12e+1. What is the difference between the Expenses (in $) of Austria in 2007 and the Expenses (in $) of New Zealand in 2008?
Offer a very short reply. -2.82e+09. What is the difference between the Expenses (in $) of Cyprus in 2007 and the Expenses (in $) of Lesotho in 2008?
Your answer should be very brief. 1.32e+09. What is the difference between the Expenses (in $) of Cyprus in 2007 and the Expenses (in $) of New Zealand in 2008?
Offer a very short reply. -1.27e+1. What is the difference between the Expenses (in $) in Lesotho in 2007 and the Expenses (in $) in New Zealand in 2008?
Give a very brief answer. -1.45e+1. What is the average Expenses (in $) in Austria per year?
Ensure brevity in your answer.  1.24e+1. What is the average Expenses (in $) in Cyprus per year?
Make the answer very short. 3.15e+09. What is the average Expenses (in $) of Lesotho per year?
Your answer should be compact. 1.48e+09. What is the average Expenses (in $) of New Zealand per year?
Your answer should be compact. 1.28e+1. In the year 2001, what is the difference between the Expenses (in $) of Austria and Expenses (in $) of Cyprus?
Provide a succinct answer. 8.94e+09. In the year 2001, what is the difference between the Expenses (in $) in Austria and Expenses (in $) in Lesotho?
Provide a succinct answer. 1.02e+1. In the year 2001, what is the difference between the Expenses (in $) of Austria and Expenses (in $) of New Zealand?
Keep it short and to the point. 9.00e+08. In the year 2001, what is the difference between the Expenses (in $) in Cyprus and Expenses (in $) in Lesotho?
Offer a very short reply. 1.28e+09. In the year 2001, what is the difference between the Expenses (in $) in Cyprus and Expenses (in $) in New Zealand?
Provide a short and direct response. -8.04e+09. In the year 2001, what is the difference between the Expenses (in $) of Lesotho and Expenses (in $) of New Zealand?
Ensure brevity in your answer.  -9.32e+09. In the year 2002, what is the difference between the Expenses (in $) of Austria and Expenses (in $) of Cyprus?
Provide a short and direct response. 8.84e+09. In the year 2002, what is the difference between the Expenses (in $) in Austria and Expenses (in $) in Lesotho?
Provide a short and direct response. 1.02e+1. In the year 2002, what is the difference between the Expenses (in $) of Austria and Expenses (in $) of New Zealand?
Ensure brevity in your answer.  -6.80e+07. In the year 2002, what is the difference between the Expenses (in $) in Cyprus and Expenses (in $) in Lesotho?
Offer a very short reply. 1.37e+09. In the year 2002, what is the difference between the Expenses (in $) of Cyprus and Expenses (in $) of New Zealand?
Provide a short and direct response. -8.91e+09. In the year 2002, what is the difference between the Expenses (in $) of Lesotho and Expenses (in $) of New Zealand?
Provide a short and direct response. -1.03e+1. In the year 2003, what is the difference between the Expenses (in $) of Austria and Expenses (in $) of Cyprus?
Provide a short and direct response. 8.68e+09. In the year 2003, what is the difference between the Expenses (in $) of Austria and Expenses (in $) of Lesotho?
Offer a very short reply. 1.05e+1. In the year 2003, what is the difference between the Expenses (in $) in Austria and Expenses (in $) in New Zealand?
Give a very brief answer. 7.31e+08. In the year 2003, what is the difference between the Expenses (in $) in Cyprus and Expenses (in $) in Lesotho?
Provide a succinct answer. 1.80e+09. In the year 2003, what is the difference between the Expenses (in $) of Cyprus and Expenses (in $) of New Zealand?
Offer a very short reply. -7.94e+09. In the year 2003, what is the difference between the Expenses (in $) of Lesotho and Expenses (in $) of New Zealand?
Offer a terse response. -9.74e+09. In the year 2004, what is the difference between the Expenses (in $) of Austria and Expenses (in $) of Cyprus?
Give a very brief answer. 8.75e+09. In the year 2004, what is the difference between the Expenses (in $) of Austria and Expenses (in $) of Lesotho?
Your answer should be very brief. 1.06e+1. In the year 2004, what is the difference between the Expenses (in $) of Austria and Expenses (in $) of New Zealand?
Make the answer very short. -1.39e+08. In the year 2004, what is the difference between the Expenses (in $) in Cyprus and Expenses (in $) in Lesotho?
Ensure brevity in your answer.  1.81e+09. In the year 2004, what is the difference between the Expenses (in $) of Cyprus and Expenses (in $) of New Zealand?
Ensure brevity in your answer.  -8.89e+09. In the year 2004, what is the difference between the Expenses (in $) of Lesotho and Expenses (in $) of New Zealand?
Make the answer very short. -1.07e+1. In the year 2005, what is the difference between the Expenses (in $) of Austria and Expenses (in $) of Cyprus?
Keep it short and to the point. 9.19e+09. In the year 2005, what is the difference between the Expenses (in $) in Austria and Expenses (in $) in Lesotho?
Your answer should be very brief. 1.10e+1. In the year 2005, what is the difference between the Expenses (in $) of Austria and Expenses (in $) of New Zealand?
Your response must be concise. -5.29e+08. In the year 2005, what is the difference between the Expenses (in $) of Cyprus and Expenses (in $) of Lesotho?
Your response must be concise. 1.86e+09. In the year 2005, what is the difference between the Expenses (in $) in Cyprus and Expenses (in $) in New Zealand?
Ensure brevity in your answer.  -9.72e+09. In the year 2005, what is the difference between the Expenses (in $) in Lesotho and Expenses (in $) in New Zealand?
Provide a short and direct response. -1.16e+1. In the year 2006, what is the difference between the Expenses (in $) of Austria and Expenses (in $) of Cyprus?
Keep it short and to the point. 9.73e+09. In the year 2006, what is the difference between the Expenses (in $) of Austria and Expenses (in $) of Lesotho?
Offer a terse response. 1.15e+1. In the year 2006, what is the difference between the Expenses (in $) in Austria and Expenses (in $) in New Zealand?
Offer a terse response. -7.77e+08. In the year 2006, what is the difference between the Expenses (in $) of Cyprus and Expenses (in $) of Lesotho?
Make the answer very short. 1.78e+09. In the year 2006, what is the difference between the Expenses (in $) of Cyprus and Expenses (in $) of New Zealand?
Make the answer very short. -1.05e+1. In the year 2006, what is the difference between the Expenses (in $) in Lesotho and Expenses (in $) in New Zealand?
Make the answer very short. -1.23e+1. In the year 2007, what is the difference between the Expenses (in $) in Austria and Expenses (in $) in Cyprus?
Offer a very short reply. 9.84e+09. In the year 2007, what is the difference between the Expenses (in $) in Austria and Expenses (in $) in Lesotho?
Give a very brief answer. 1.17e+1. In the year 2007, what is the difference between the Expenses (in $) in Austria and Expenses (in $) in New Zealand?
Offer a very short reply. -1.02e+09. In the year 2007, what is the difference between the Expenses (in $) of Cyprus and Expenses (in $) of Lesotho?
Offer a very short reply. 1.83e+09. In the year 2007, what is the difference between the Expenses (in $) of Cyprus and Expenses (in $) of New Zealand?
Offer a very short reply. -1.09e+1. In the year 2007, what is the difference between the Expenses (in $) in Lesotho and Expenses (in $) in New Zealand?
Offer a terse response. -1.27e+1. In the year 2008, what is the difference between the Expenses (in $) in Austria and Expenses (in $) in Cyprus?
Your answer should be compact. 1.02e+1. In the year 2008, what is the difference between the Expenses (in $) in Austria and Expenses (in $) in Lesotho?
Your answer should be very brief. 1.18e+1. In the year 2008, what is the difference between the Expenses (in $) of Austria and Expenses (in $) of New Zealand?
Give a very brief answer. -2.18e+09. In the year 2008, what is the difference between the Expenses (in $) of Cyprus and Expenses (in $) of Lesotho?
Keep it short and to the point. 1.63e+09. In the year 2008, what is the difference between the Expenses (in $) of Cyprus and Expenses (in $) of New Zealand?
Offer a terse response. -1.23e+1. In the year 2008, what is the difference between the Expenses (in $) of Lesotho and Expenses (in $) of New Zealand?
Your answer should be very brief. -1.40e+1. What is the ratio of the Expenses (in $) of Austria in 2001 to that in 2002?
Ensure brevity in your answer.  0.99. What is the ratio of the Expenses (in $) of Cyprus in 2001 to that in 2002?
Ensure brevity in your answer.  0.93. What is the ratio of the Expenses (in $) in Lesotho in 2001 to that in 2002?
Provide a succinct answer. 0.92. What is the ratio of the Expenses (in $) of New Zealand in 2001 to that in 2002?
Offer a very short reply. 0.91. What is the ratio of the Expenses (in $) of Austria in 2001 to that in 2003?
Keep it short and to the point. 0.96. What is the ratio of the Expenses (in $) in Cyprus in 2001 to that in 2003?
Your answer should be very brief. 0.77. What is the ratio of the Expenses (in $) in Lesotho in 2001 to that in 2003?
Offer a very short reply. 0.84. What is the ratio of the Expenses (in $) in New Zealand in 2001 to that in 2003?
Make the answer very short. 0.94. What is the ratio of the Expenses (in $) in Austria in 2001 to that in 2004?
Keep it short and to the point. 0.95. What is the ratio of the Expenses (in $) of Cyprus in 2001 to that in 2004?
Your answer should be compact. 0.75. What is the ratio of the Expenses (in $) in Lesotho in 2001 to that in 2004?
Your response must be concise. 0.8. What is the ratio of the Expenses (in $) in New Zealand in 2001 to that in 2004?
Your answer should be very brief. 0.86. What is the ratio of the Expenses (in $) in Austria in 2001 to that in 2005?
Ensure brevity in your answer.  0.9. What is the ratio of the Expenses (in $) of Cyprus in 2001 to that in 2005?
Provide a short and direct response. 0.71. What is the ratio of the Expenses (in $) of Lesotho in 2001 to that in 2005?
Offer a very short reply. 0.73. What is the ratio of the Expenses (in $) of New Zealand in 2001 to that in 2005?
Ensure brevity in your answer.  0.8. What is the ratio of the Expenses (in $) in Austria in 2001 to that in 2006?
Offer a terse response. 0.85. What is the ratio of the Expenses (in $) in Cyprus in 2001 to that in 2006?
Provide a short and direct response. 0.66. What is the ratio of the Expenses (in $) of Lesotho in 2001 to that in 2006?
Your answer should be compact. 0.6. What is the ratio of the Expenses (in $) of New Zealand in 2001 to that in 2006?
Your answer should be compact. 0.74. What is the ratio of the Expenses (in $) of Austria in 2001 to that in 2007?
Offer a terse response. 0.83. What is the ratio of the Expenses (in $) in Cyprus in 2001 to that in 2007?
Your answer should be compact. 0.61. What is the ratio of the Expenses (in $) in Lesotho in 2001 to that in 2007?
Give a very brief answer. 0.52. What is the ratio of the Expenses (in $) of New Zealand in 2001 to that in 2007?
Offer a very short reply. 0.71. What is the ratio of the Expenses (in $) of Austria in 2001 to that in 2008?
Your response must be concise. 0.79. What is the ratio of the Expenses (in $) of Cyprus in 2001 to that in 2008?
Offer a very short reply. 0.56. What is the ratio of the Expenses (in $) in Lesotho in 2001 to that in 2008?
Provide a succinct answer. 0.41. What is the ratio of the Expenses (in $) in New Zealand in 2001 to that in 2008?
Make the answer very short. 0.63. What is the ratio of the Expenses (in $) of Austria in 2002 to that in 2003?
Offer a very short reply. 0.97. What is the ratio of the Expenses (in $) of Cyprus in 2002 to that in 2003?
Offer a very short reply. 0.82. What is the ratio of the Expenses (in $) of Lesotho in 2002 to that in 2003?
Your answer should be compact. 0.92. What is the ratio of the Expenses (in $) in New Zealand in 2002 to that in 2003?
Your answer should be compact. 1.04. What is the ratio of the Expenses (in $) of Austria in 2002 to that in 2004?
Your response must be concise. 0.96. What is the ratio of the Expenses (in $) in Cyprus in 2002 to that in 2004?
Keep it short and to the point. 0.8. What is the ratio of the Expenses (in $) in Lesotho in 2002 to that in 2004?
Your answer should be compact. 0.87. What is the ratio of the Expenses (in $) of New Zealand in 2002 to that in 2004?
Your answer should be very brief. 0.95. What is the ratio of the Expenses (in $) in Austria in 2002 to that in 2005?
Ensure brevity in your answer.  0.91. What is the ratio of the Expenses (in $) in Cyprus in 2002 to that in 2005?
Your answer should be very brief. 0.76. What is the ratio of the Expenses (in $) in Lesotho in 2002 to that in 2005?
Provide a succinct answer. 0.8. What is the ratio of the Expenses (in $) in New Zealand in 2002 to that in 2005?
Offer a very short reply. 0.88. What is the ratio of the Expenses (in $) of Austria in 2002 to that in 2006?
Give a very brief answer. 0.86. What is the ratio of the Expenses (in $) in Cyprus in 2002 to that in 2006?
Ensure brevity in your answer.  0.71. What is the ratio of the Expenses (in $) in Lesotho in 2002 to that in 2006?
Provide a succinct answer. 0.65. What is the ratio of the Expenses (in $) in New Zealand in 2002 to that in 2006?
Offer a terse response. 0.81. What is the ratio of the Expenses (in $) in Austria in 2002 to that in 2007?
Keep it short and to the point. 0.83. What is the ratio of the Expenses (in $) in Cyprus in 2002 to that in 2007?
Your answer should be very brief. 0.65. What is the ratio of the Expenses (in $) of Lesotho in 2002 to that in 2007?
Your answer should be compact. 0.56. What is the ratio of the Expenses (in $) in New Zealand in 2002 to that in 2007?
Ensure brevity in your answer.  0.78. What is the ratio of the Expenses (in $) in Austria in 2002 to that in 2008?
Your answer should be compact. 0.79. What is the ratio of the Expenses (in $) of Cyprus in 2002 to that in 2008?
Provide a short and direct response. 0.6. What is the ratio of the Expenses (in $) of Lesotho in 2002 to that in 2008?
Your answer should be very brief. 0.45. What is the ratio of the Expenses (in $) in New Zealand in 2002 to that in 2008?
Give a very brief answer. 0.69. What is the ratio of the Expenses (in $) of Austria in 2003 to that in 2004?
Provide a succinct answer. 0.99. What is the ratio of the Expenses (in $) in Cyprus in 2003 to that in 2004?
Provide a short and direct response. 0.97. What is the ratio of the Expenses (in $) of Lesotho in 2003 to that in 2004?
Offer a very short reply. 0.95. What is the ratio of the Expenses (in $) in New Zealand in 2003 to that in 2004?
Make the answer very short. 0.91. What is the ratio of the Expenses (in $) of Austria in 2003 to that in 2005?
Keep it short and to the point. 0.94. What is the ratio of the Expenses (in $) of Cyprus in 2003 to that in 2005?
Your response must be concise. 0.92. What is the ratio of the Expenses (in $) in Lesotho in 2003 to that in 2005?
Your response must be concise. 0.87. What is the ratio of the Expenses (in $) of New Zealand in 2003 to that in 2005?
Offer a very short reply. 0.84. What is the ratio of the Expenses (in $) in Austria in 2003 to that in 2006?
Your response must be concise. 0.88. What is the ratio of the Expenses (in $) in Cyprus in 2003 to that in 2006?
Your answer should be very brief. 0.86. What is the ratio of the Expenses (in $) in Lesotho in 2003 to that in 2006?
Your answer should be compact. 0.71. What is the ratio of the Expenses (in $) in New Zealand in 2003 to that in 2006?
Provide a succinct answer. 0.78. What is the ratio of the Expenses (in $) of Austria in 2003 to that in 2007?
Offer a very short reply. 0.86. What is the ratio of the Expenses (in $) in Cyprus in 2003 to that in 2007?
Ensure brevity in your answer.  0.79. What is the ratio of the Expenses (in $) of Lesotho in 2003 to that in 2007?
Provide a succinct answer. 0.61. What is the ratio of the Expenses (in $) of New Zealand in 2003 to that in 2007?
Ensure brevity in your answer.  0.75. What is the ratio of the Expenses (in $) of Austria in 2003 to that in 2008?
Your answer should be compact. 0.82. What is the ratio of the Expenses (in $) of Cyprus in 2003 to that in 2008?
Provide a short and direct response. 0.73. What is the ratio of the Expenses (in $) of Lesotho in 2003 to that in 2008?
Provide a succinct answer. 0.48. What is the ratio of the Expenses (in $) in New Zealand in 2003 to that in 2008?
Your response must be concise. 0.67. What is the ratio of the Expenses (in $) in Austria in 2004 to that in 2005?
Your response must be concise. 0.95. What is the ratio of the Expenses (in $) in Cyprus in 2004 to that in 2005?
Provide a short and direct response. 0.95. What is the ratio of the Expenses (in $) in Lesotho in 2004 to that in 2005?
Offer a very short reply. 0.91. What is the ratio of the Expenses (in $) of New Zealand in 2004 to that in 2005?
Keep it short and to the point. 0.92. What is the ratio of the Expenses (in $) of Austria in 2004 to that in 2006?
Offer a terse response. 0.9. What is the ratio of the Expenses (in $) in Cyprus in 2004 to that in 2006?
Keep it short and to the point. 0.88. What is the ratio of the Expenses (in $) of Lesotho in 2004 to that in 2006?
Provide a succinct answer. 0.74. What is the ratio of the Expenses (in $) in New Zealand in 2004 to that in 2006?
Your answer should be compact. 0.86. What is the ratio of the Expenses (in $) in Austria in 2004 to that in 2007?
Your answer should be very brief. 0.87. What is the ratio of the Expenses (in $) in Cyprus in 2004 to that in 2007?
Your response must be concise. 0.81. What is the ratio of the Expenses (in $) in Lesotho in 2004 to that in 2007?
Give a very brief answer. 0.65. What is the ratio of the Expenses (in $) in New Zealand in 2004 to that in 2007?
Keep it short and to the point. 0.82. What is the ratio of the Expenses (in $) in Austria in 2004 to that in 2008?
Provide a short and direct response. 0.83. What is the ratio of the Expenses (in $) of Cyprus in 2004 to that in 2008?
Ensure brevity in your answer.  0.75. What is the ratio of the Expenses (in $) of Lesotho in 2004 to that in 2008?
Keep it short and to the point. 0.51. What is the ratio of the Expenses (in $) of New Zealand in 2004 to that in 2008?
Your answer should be very brief. 0.73. What is the ratio of the Expenses (in $) of Austria in 2005 to that in 2006?
Your answer should be compact. 0.94. What is the ratio of the Expenses (in $) in Cyprus in 2005 to that in 2006?
Make the answer very short. 0.93. What is the ratio of the Expenses (in $) of Lesotho in 2005 to that in 2006?
Make the answer very short. 0.82. What is the ratio of the Expenses (in $) in New Zealand in 2005 to that in 2006?
Give a very brief answer. 0.93. What is the ratio of the Expenses (in $) in Austria in 2005 to that in 2007?
Give a very brief answer. 0.91. What is the ratio of the Expenses (in $) in Cyprus in 2005 to that in 2007?
Give a very brief answer. 0.86. What is the ratio of the Expenses (in $) of Lesotho in 2005 to that in 2007?
Offer a terse response. 0.71. What is the ratio of the Expenses (in $) of New Zealand in 2005 to that in 2007?
Ensure brevity in your answer.  0.89. What is the ratio of the Expenses (in $) of Austria in 2005 to that in 2008?
Ensure brevity in your answer.  0.87. What is the ratio of the Expenses (in $) of Cyprus in 2005 to that in 2008?
Offer a terse response. 0.79. What is the ratio of the Expenses (in $) of Lesotho in 2005 to that in 2008?
Offer a terse response. 0.56. What is the ratio of the Expenses (in $) in New Zealand in 2005 to that in 2008?
Give a very brief answer. 0.79. What is the ratio of the Expenses (in $) of Austria in 2006 to that in 2007?
Your response must be concise. 0.97. What is the ratio of the Expenses (in $) in Cyprus in 2006 to that in 2007?
Keep it short and to the point. 0.92. What is the ratio of the Expenses (in $) of Lesotho in 2006 to that in 2007?
Provide a succinct answer. 0.87. What is the ratio of the Expenses (in $) in New Zealand in 2006 to that in 2007?
Keep it short and to the point. 0.96. What is the ratio of the Expenses (in $) in Austria in 2006 to that in 2008?
Give a very brief answer. 0.93. What is the ratio of the Expenses (in $) of Cyprus in 2006 to that in 2008?
Ensure brevity in your answer.  0.85. What is the ratio of the Expenses (in $) in Lesotho in 2006 to that in 2008?
Your answer should be compact. 0.69. What is the ratio of the Expenses (in $) in New Zealand in 2006 to that in 2008?
Keep it short and to the point. 0.85. What is the ratio of the Expenses (in $) in Austria in 2007 to that in 2008?
Your answer should be compact. 0.96. What is the ratio of the Expenses (in $) in Cyprus in 2007 to that in 2008?
Your answer should be compact. 0.92. What is the ratio of the Expenses (in $) in Lesotho in 2007 to that in 2008?
Keep it short and to the point. 0.79. What is the ratio of the Expenses (in $) of New Zealand in 2007 to that in 2008?
Provide a succinct answer. 0.89. What is the difference between the highest and the second highest Expenses (in $) in Austria?
Keep it short and to the point. 6.39e+08. What is the difference between the highest and the second highest Expenses (in $) in Cyprus?
Your answer should be compact. 3.10e+08. What is the difference between the highest and the second highest Expenses (in $) in Lesotho?
Offer a terse response. 5.13e+08. What is the difference between the highest and the second highest Expenses (in $) of New Zealand?
Make the answer very short. 1.80e+09. What is the difference between the highest and the lowest Expenses (in $) of Austria?
Provide a short and direct response. 3.01e+09. What is the difference between the highest and the lowest Expenses (in $) in Cyprus?
Your response must be concise. 1.78e+09. What is the difference between the highest and the lowest Expenses (in $) in Lesotho?
Keep it short and to the point. 1.44e+09. What is the difference between the highest and the lowest Expenses (in $) of New Zealand?
Offer a very short reply. 6.09e+09. 